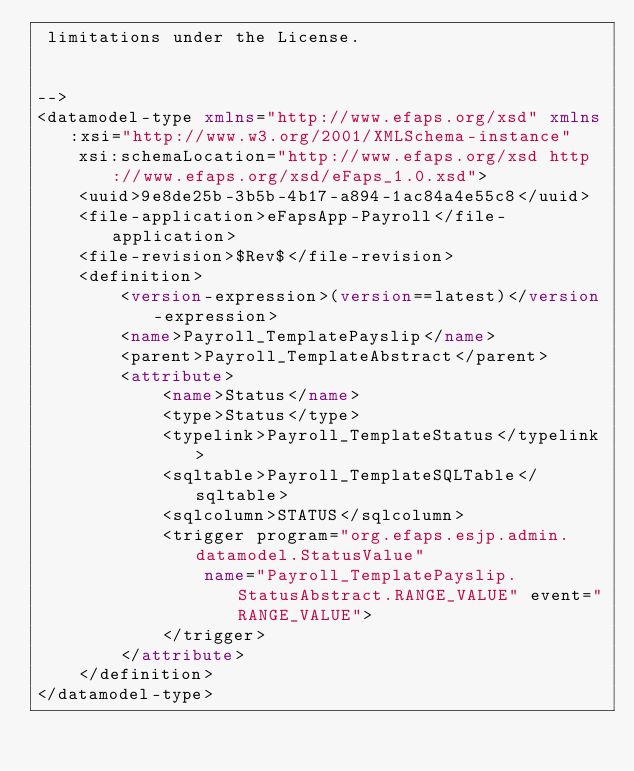Convert code to text. <code><loc_0><loc_0><loc_500><loc_500><_XML_> limitations under the License.


-->
<datamodel-type xmlns="http://www.efaps.org/xsd" xmlns:xsi="http://www.w3.org/2001/XMLSchema-instance"
    xsi:schemaLocation="http://www.efaps.org/xsd http://www.efaps.org/xsd/eFaps_1.0.xsd">
    <uuid>9e8de25b-3b5b-4b17-a894-1ac84a4e55c8</uuid>
    <file-application>eFapsApp-Payroll</file-application>
    <file-revision>$Rev$</file-revision>
    <definition>
        <version-expression>(version==latest)</version-expression>
        <name>Payroll_TemplatePayslip</name>
        <parent>Payroll_TemplateAbstract</parent>
        <attribute>
            <name>Status</name>
            <type>Status</type>
            <typelink>Payroll_TemplateStatus</typelink>
            <sqltable>Payroll_TemplateSQLTable</sqltable>
            <sqlcolumn>STATUS</sqlcolumn>
            <trigger program="org.efaps.esjp.admin.datamodel.StatusValue"
                name="Payroll_TemplatePayslip.StatusAbstract.RANGE_VALUE" event="RANGE_VALUE">
            </trigger>
        </attribute>
    </definition>
</datamodel-type>
</code> 